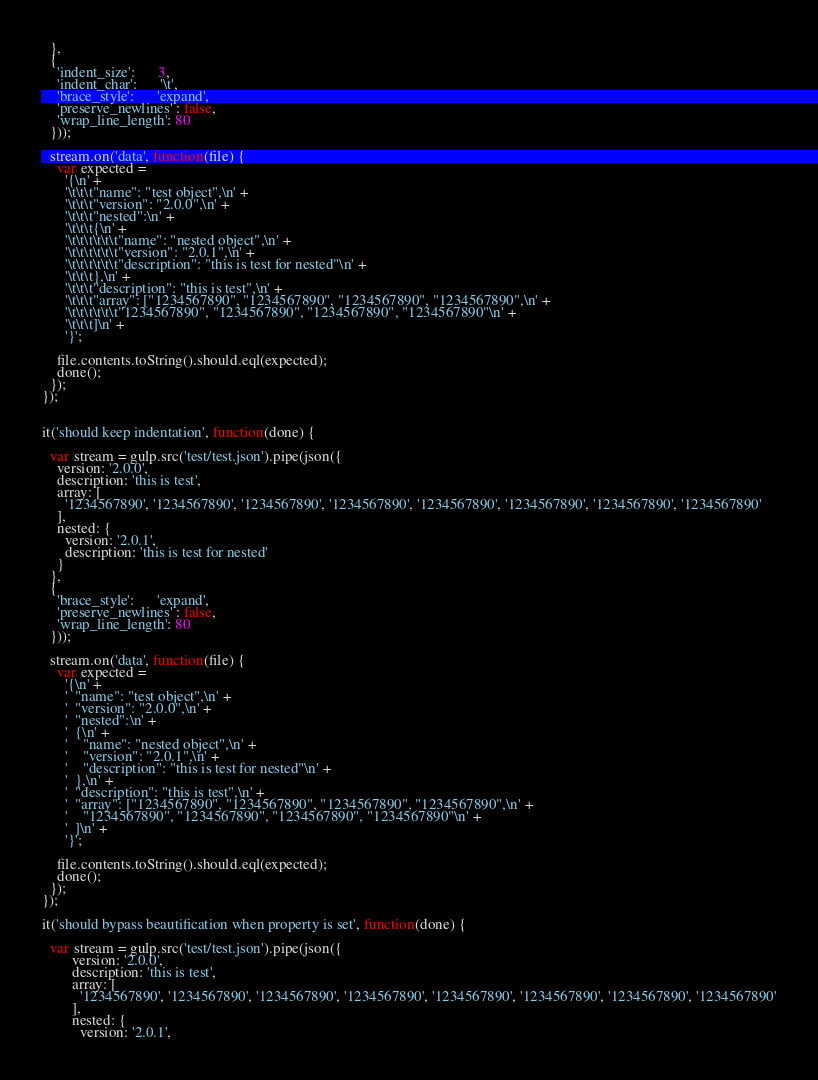Convert code to text. <code><loc_0><loc_0><loc_500><loc_500><_JavaScript_>  },
  {
    'indent_size':      3,
    'indent_char':      '\t',
    'brace_style':      'expand',
    'preserve_newlines' : false,
    'wrap_line_length': 80
  }));

  stream.on('data', function(file) {
    var expected =
      '{\n' +
      '\t\t\t"name": "test object",\n' +
      '\t\t\t"version": "2.0.0",\n' +
      '\t\t\t"nested":\n' +
      '\t\t\t{\n' +
      '\t\t\t\t\t\t"name": "nested object",\n' +
      '\t\t\t\t\t\t"version": "2.0.1",\n' +
      '\t\t\t\t\t\t"description": "this is test for nested"\n' +
      '\t\t\t},\n' +
      '\t\t\t"description": "this is test",\n' +
      '\t\t\t"array": ["1234567890", "1234567890", "1234567890", "1234567890",\n' +
      '\t\t\t\t\t\t"1234567890", "1234567890", "1234567890", "1234567890"\n' +
      '\t\t\t]\n' +
      '}';

    file.contents.toString().should.eql(expected);
    done();
  });
});


it('should keep indentation', function(done) {

  var stream = gulp.src('test/test.json').pipe(json({
    version: '2.0.0',
    description: 'this is test',
    array: [
      '1234567890', '1234567890', '1234567890', '1234567890', '1234567890', '1234567890', '1234567890', '1234567890'
    ],
    nested: {
      version: '2.0.1',
      description: 'this is test for nested'
    }
  },
  {
    'brace_style':      'expand',
    'preserve_newlines' : false,
    'wrap_line_length': 80
  }));

  stream.on('data', function(file) {
    var expected =
      '{\n' +
      '  "name": "test object",\n' +
      '  "version": "2.0.0",\n' +
      '  "nested":\n' +
      '  {\n' +
      '    "name": "nested object",\n' +
      '    "version": "2.0.1",\n' +
      '    "description": "this is test for nested"\n' +
      '  },\n' +
      '  "description": "this is test",\n' +
      '  "array": ["1234567890", "1234567890", "1234567890", "1234567890",\n' +
      '    "1234567890", "1234567890", "1234567890", "1234567890"\n' +
      '  ]\n' +
      '}';

    file.contents.toString().should.eql(expected);
    done();
  });
});

it('should bypass beautification when property is set', function(done) {

  var stream = gulp.src('test/test.json').pipe(json({
        version: '2.0.0',
        description: 'this is test',
        array: [
          '1234567890', '1234567890', '1234567890', '1234567890', '1234567890', '1234567890', '1234567890', '1234567890'
        ],
        nested: {
          version: '2.0.1',</code> 